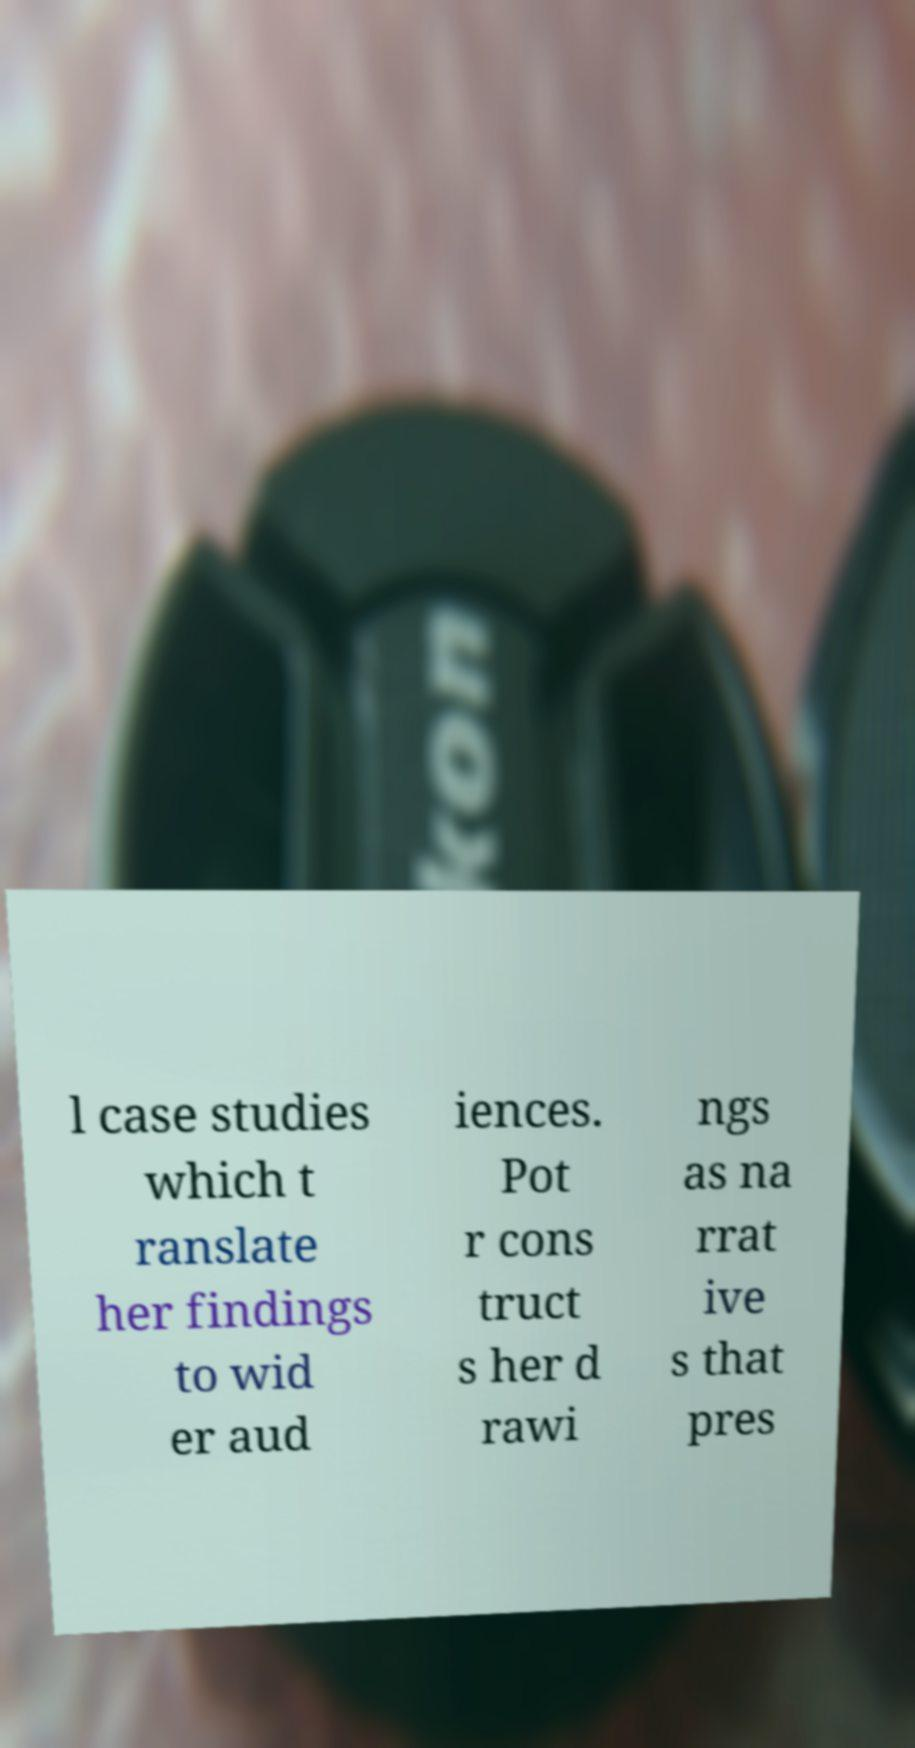Please identify and transcribe the text found in this image. l case studies which t ranslate her findings to wid er aud iences. Pot r cons truct s her d rawi ngs as na rrat ive s that pres 